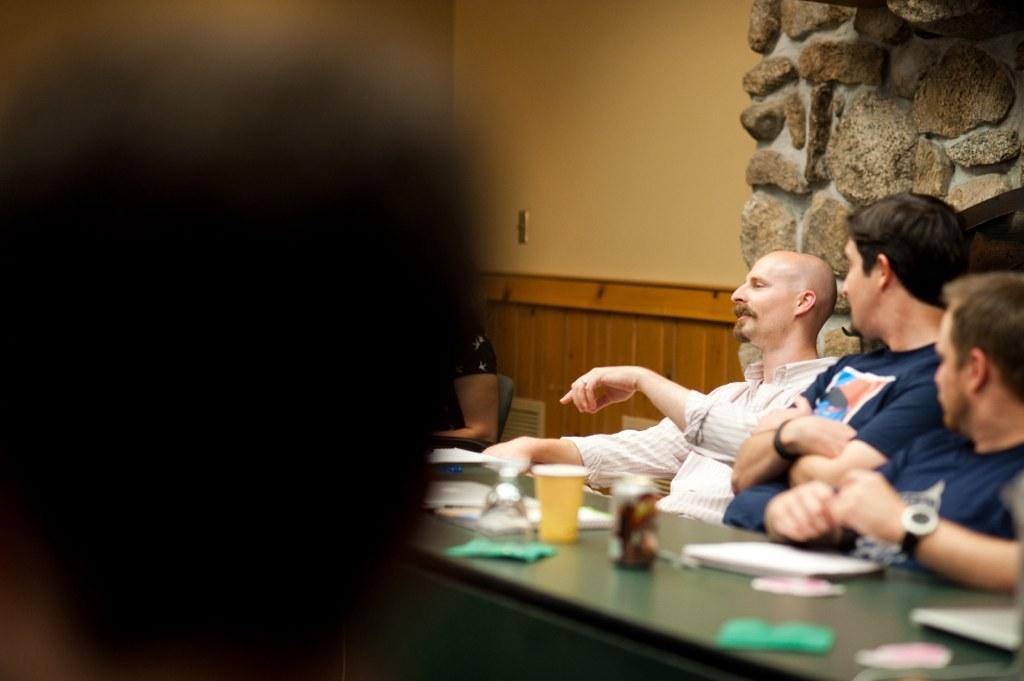In one or two sentences, can you explain what this image depicts? In this image, we can see people sitting on the chairs and there are papers, a cup and some other objects on the table. In the background, there is a rock wall. 